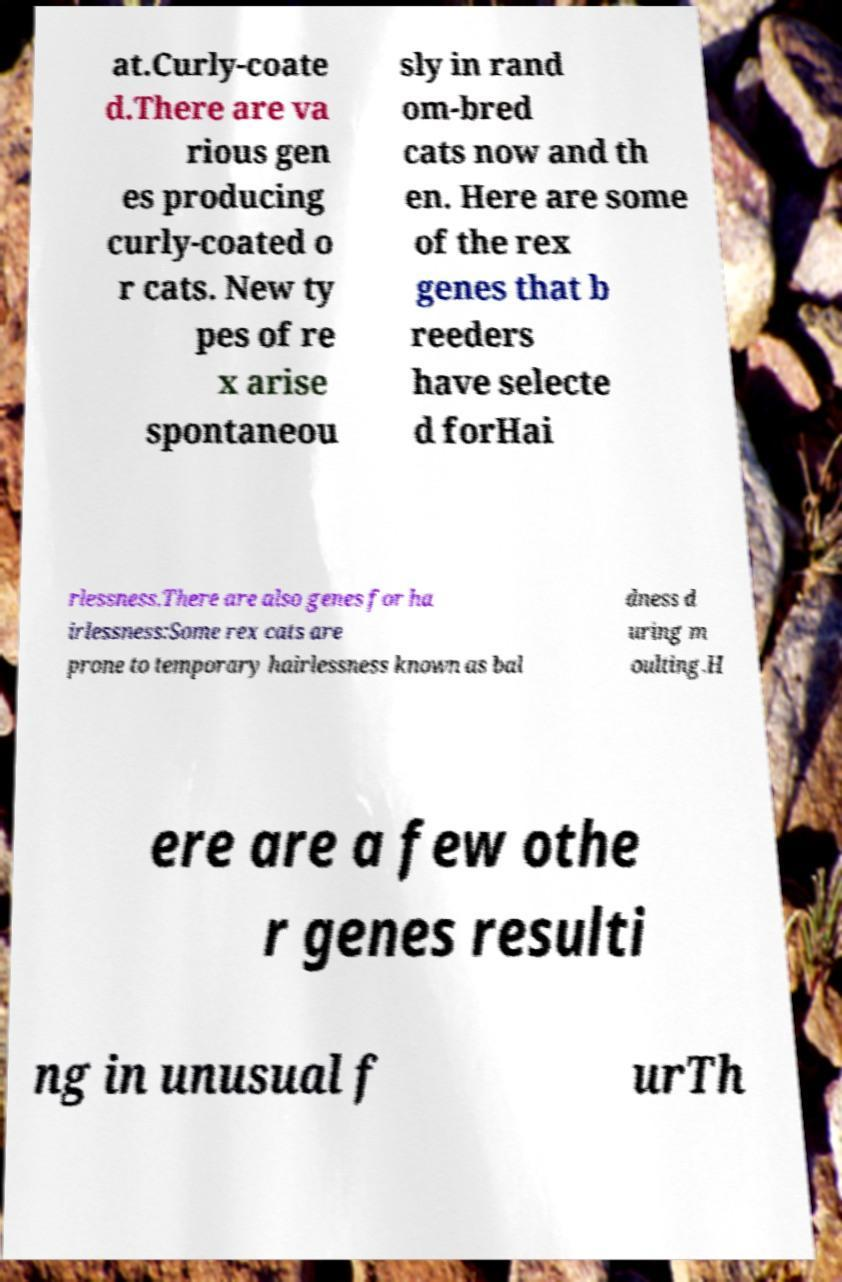What messages or text are displayed in this image? I need them in a readable, typed format. at.Curly-coate d.There are va rious gen es producing curly-coated o r cats. New ty pes of re x arise spontaneou sly in rand om-bred cats now and th en. Here are some of the rex genes that b reeders have selecte d forHai rlessness.There are also genes for ha irlessness:Some rex cats are prone to temporary hairlessness known as bal dness d uring m oulting.H ere are a few othe r genes resulti ng in unusual f urTh 